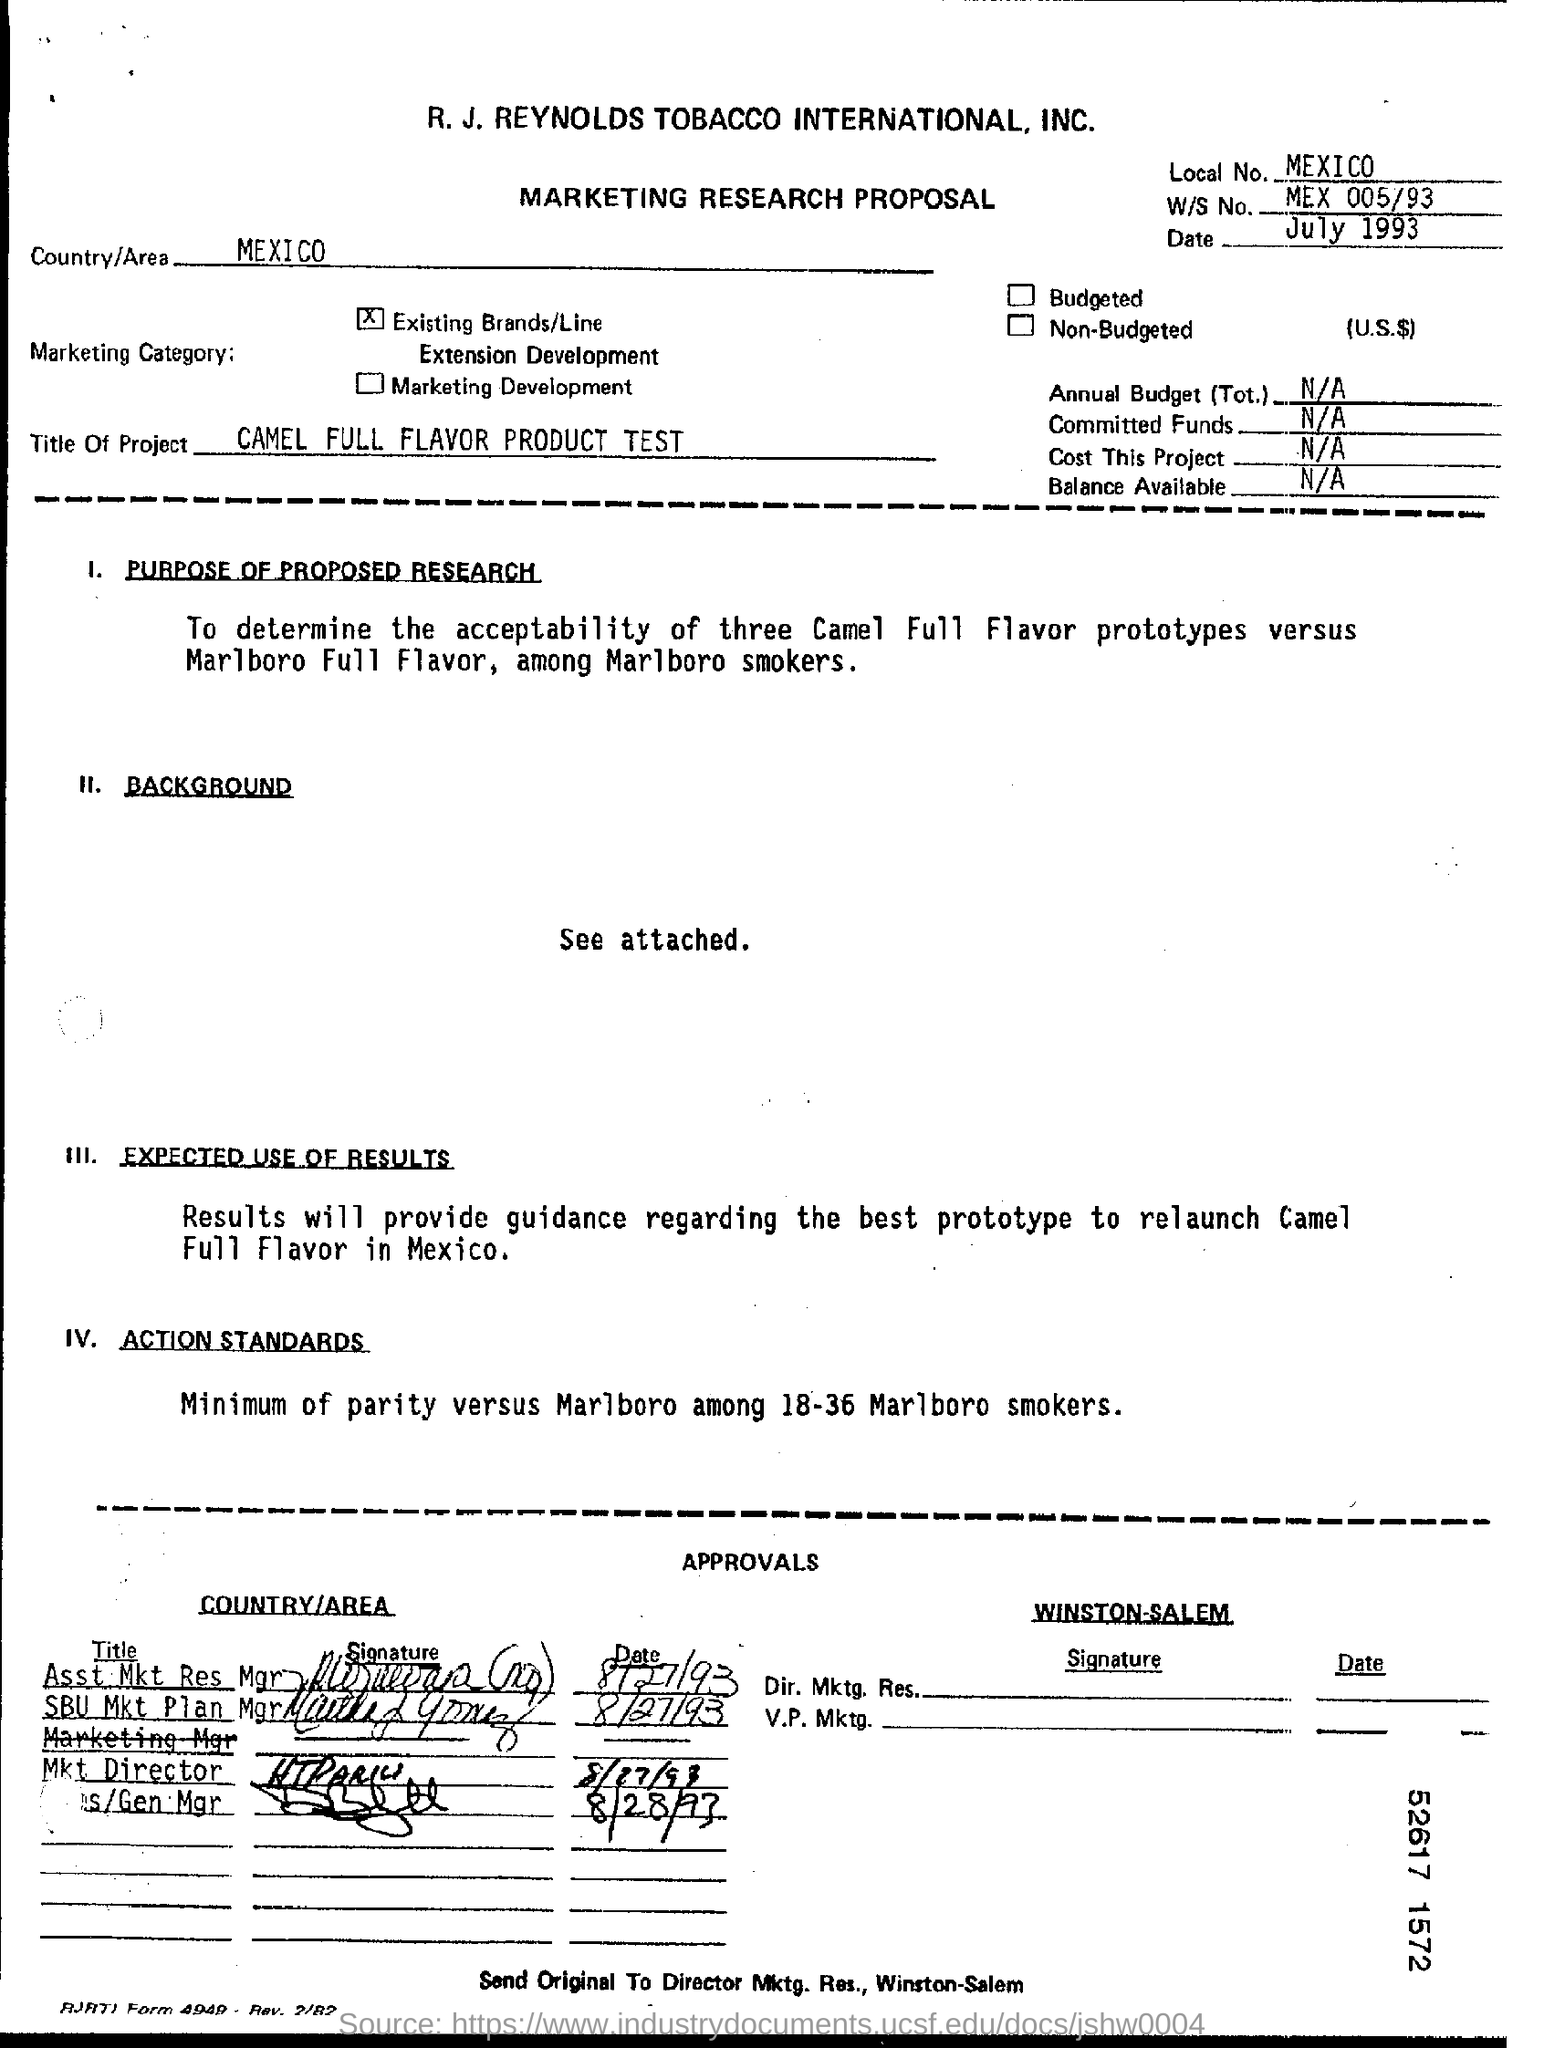What is the main heading of document ?
Ensure brevity in your answer.  MARKETING RESEARCH PROPOSAL. What is Local No ?
Make the answer very short. MEXICO. What is the date mentioned in the top of the document ?
Offer a terse response. July 1993. What is the Country Name ?
Give a very brief answer. MEXICO. What is W/S No ?
Your response must be concise. MEX 005/93. What is Title of the Project ?
Offer a terse response. CAMEL FULL FLAVOR PRODUCT TEST. 